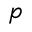Convert formula to latex. <formula><loc_0><loc_0><loc_500><loc_500>p</formula> 